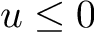Convert formula to latex. <formula><loc_0><loc_0><loc_500><loc_500>u \leq 0</formula> 